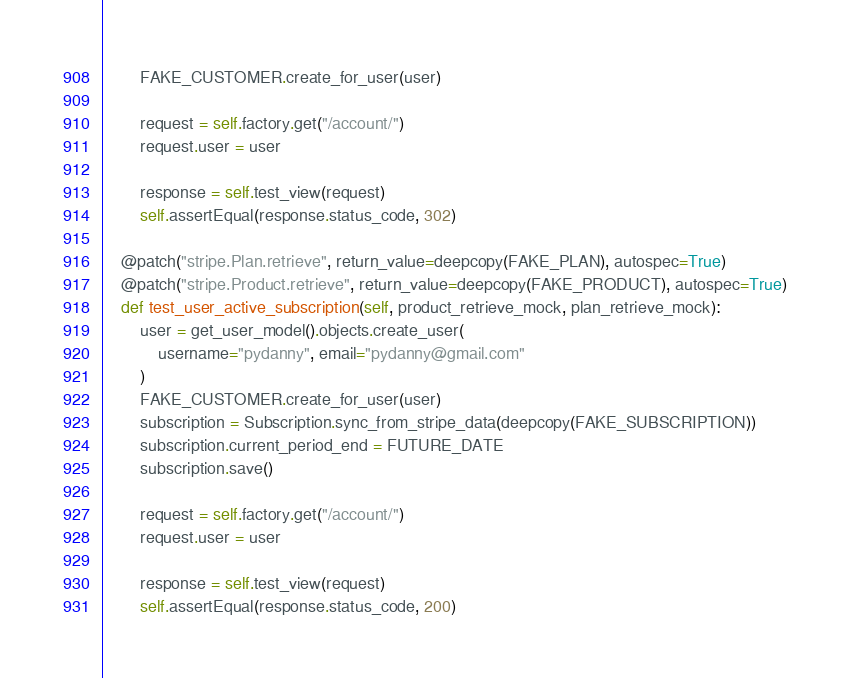<code> <loc_0><loc_0><loc_500><loc_500><_Python_>		FAKE_CUSTOMER.create_for_user(user)

		request = self.factory.get("/account/")
		request.user = user

		response = self.test_view(request)
		self.assertEqual(response.status_code, 302)

	@patch("stripe.Plan.retrieve", return_value=deepcopy(FAKE_PLAN), autospec=True)
	@patch("stripe.Product.retrieve", return_value=deepcopy(FAKE_PRODUCT), autospec=True)
	def test_user_active_subscription(self, product_retrieve_mock, plan_retrieve_mock):
		user = get_user_model().objects.create_user(
			username="pydanny", email="pydanny@gmail.com"
		)
		FAKE_CUSTOMER.create_for_user(user)
		subscription = Subscription.sync_from_stripe_data(deepcopy(FAKE_SUBSCRIPTION))
		subscription.current_period_end = FUTURE_DATE
		subscription.save()

		request = self.factory.get("/account/")
		request.user = user

		response = self.test_view(request)
		self.assertEqual(response.status_code, 200)
</code> 